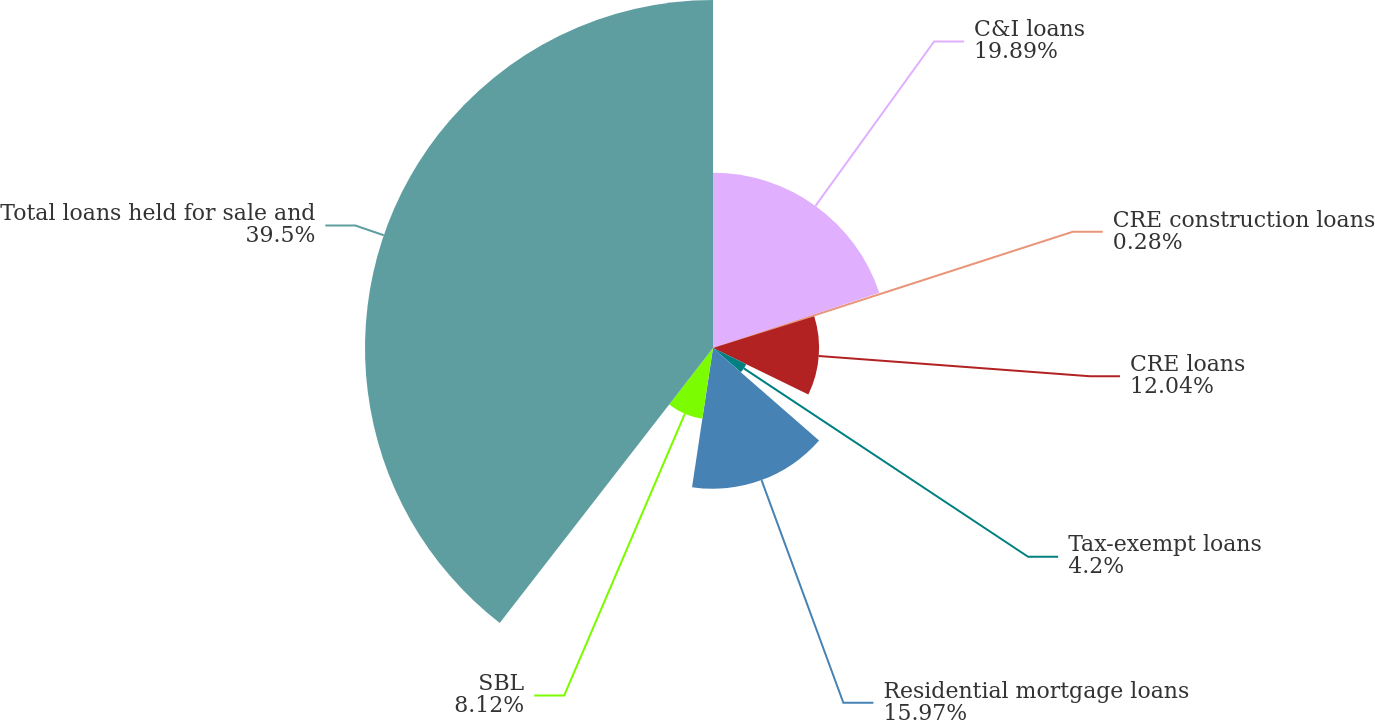<chart> <loc_0><loc_0><loc_500><loc_500><pie_chart><fcel>C&I loans<fcel>CRE construction loans<fcel>CRE loans<fcel>Tax-exempt loans<fcel>Residential mortgage loans<fcel>SBL<fcel>Total loans held for sale and<nl><fcel>19.89%<fcel>0.28%<fcel>12.04%<fcel>4.2%<fcel>15.97%<fcel>8.12%<fcel>39.5%<nl></chart> 